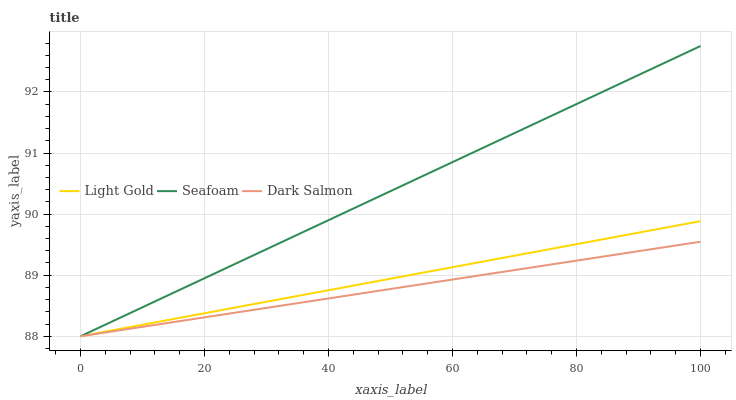Does Dark Salmon have the minimum area under the curve?
Answer yes or no. Yes. Does Seafoam have the maximum area under the curve?
Answer yes or no. Yes. Does Seafoam have the minimum area under the curve?
Answer yes or no. No. Does Dark Salmon have the maximum area under the curve?
Answer yes or no. No. Is Seafoam the smoothest?
Answer yes or no. Yes. Is Dark Salmon the roughest?
Answer yes or no. Yes. Is Dark Salmon the smoothest?
Answer yes or no. No. Is Seafoam the roughest?
Answer yes or no. No. Does Light Gold have the lowest value?
Answer yes or no. Yes. Does Seafoam have the highest value?
Answer yes or no. Yes. Does Dark Salmon have the highest value?
Answer yes or no. No. Does Light Gold intersect Seafoam?
Answer yes or no. Yes. Is Light Gold less than Seafoam?
Answer yes or no. No. Is Light Gold greater than Seafoam?
Answer yes or no. No. 